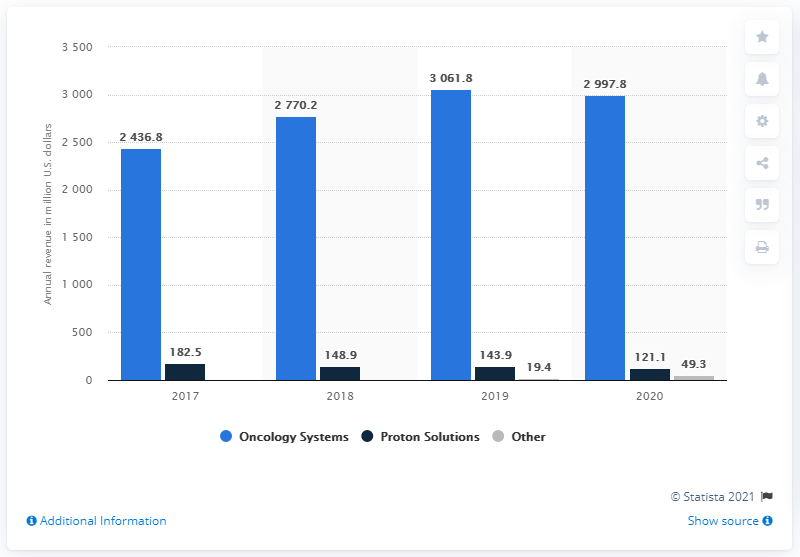Draw attention to some important aspects in this diagram. The oncology systems segment accounted for the largest portion of revenue for the entire period. The sum of the averages of annual revenues from Proton Solutions and other is 596.4. The color gray appears only once in the sequence. 